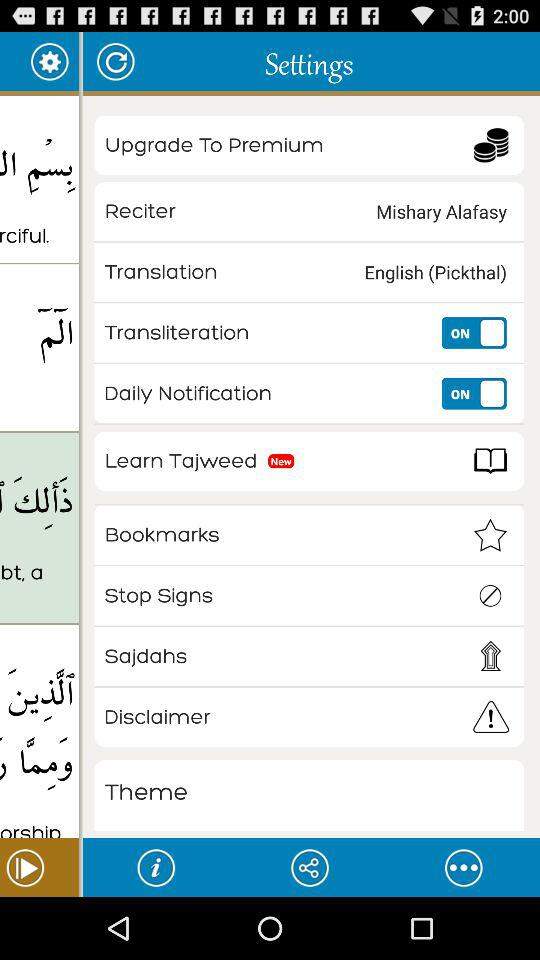What language was selected for translation? The language selected for translation is English (Pickthal). 